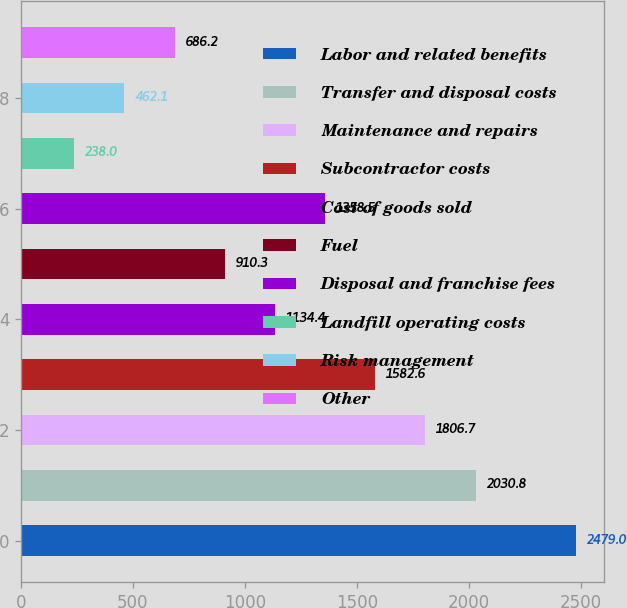<chart> <loc_0><loc_0><loc_500><loc_500><bar_chart><fcel>Labor and related benefits<fcel>Transfer and disposal costs<fcel>Maintenance and repairs<fcel>Subcontractor costs<fcel>Cost of goods sold<fcel>Fuel<fcel>Disposal and franchise fees<fcel>Landfill operating costs<fcel>Risk management<fcel>Other<nl><fcel>2479<fcel>2030.8<fcel>1806.7<fcel>1582.6<fcel>1134.4<fcel>910.3<fcel>1358.5<fcel>238<fcel>462.1<fcel>686.2<nl></chart> 